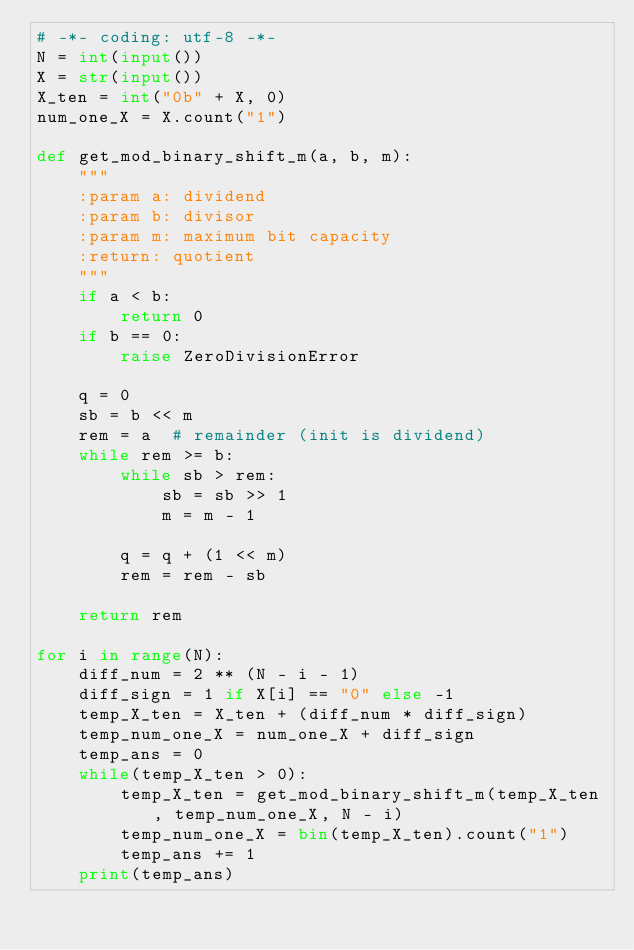Convert code to text. <code><loc_0><loc_0><loc_500><loc_500><_Python_># -*- coding: utf-8 -*-
N = int(input())
X = str(input())
X_ten = int("0b" + X, 0)
num_one_X = X.count("1")

def get_mod_binary_shift_m(a, b, m):
    """
    :param a: dividend
    :param b: divisor
    :param m: maximum bit capacity
    :return: quotient
    """
    if a < b:
        return 0
    if b == 0:
        raise ZeroDivisionError

    q = 0
    sb = b << m
    rem = a  # remainder (init is dividend)
    while rem >= b:
        while sb > rem:
            sb = sb >> 1
            m = m - 1

        q = q + (1 << m)
        rem = rem - sb

    return rem

for i in range(N):
    diff_num = 2 ** (N - i - 1)
    diff_sign = 1 if X[i] == "0" else -1
    temp_X_ten = X_ten + (diff_num * diff_sign)
    temp_num_one_X = num_one_X + diff_sign
    temp_ans = 0
    while(temp_X_ten > 0):
        temp_X_ten = get_mod_binary_shift_m(temp_X_ten, temp_num_one_X, N - i)
        temp_num_one_X = bin(temp_X_ten).count("1")
        temp_ans += 1
    print(temp_ans)</code> 